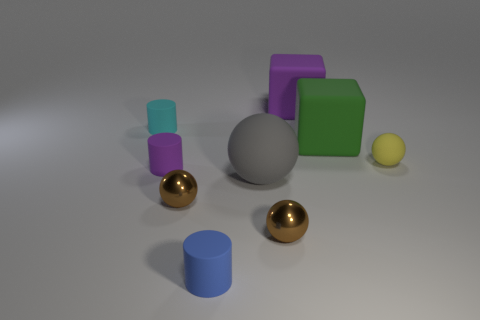Subtract all cylinders. How many objects are left? 6 Subtract all green things. Subtract all rubber blocks. How many objects are left? 6 Add 2 large green objects. How many large green objects are left? 3 Add 4 small cyan cylinders. How many small cyan cylinders exist? 5 Subtract 0 brown cylinders. How many objects are left? 9 